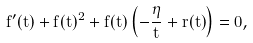<formula> <loc_0><loc_0><loc_500><loc_500>f ^ { \prime } ( t ) + f ( t ) ^ { 2 } + f ( t ) \left ( - \frac { \eta } { t } + r ( t ) \right ) = 0 ,</formula> 